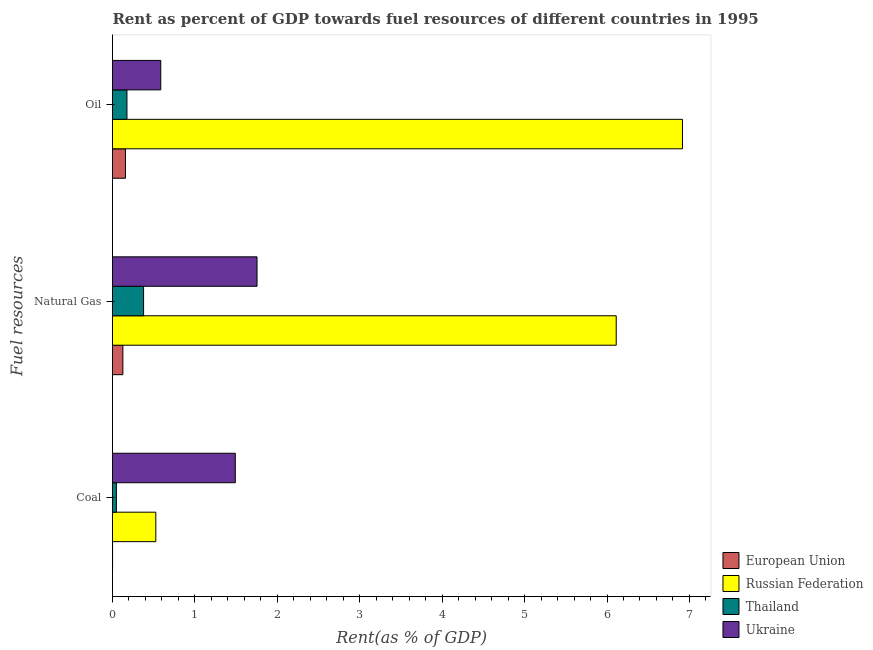How many different coloured bars are there?
Provide a succinct answer. 4. Are the number of bars per tick equal to the number of legend labels?
Provide a succinct answer. Yes. Are the number of bars on each tick of the Y-axis equal?
Provide a succinct answer. Yes. How many bars are there on the 1st tick from the top?
Ensure brevity in your answer.  4. How many bars are there on the 2nd tick from the bottom?
Your answer should be compact. 4. What is the label of the 1st group of bars from the top?
Ensure brevity in your answer.  Oil. What is the rent towards natural gas in Thailand?
Your response must be concise. 0.38. Across all countries, what is the maximum rent towards natural gas?
Your response must be concise. 6.11. Across all countries, what is the minimum rent towards natural gas?
Your response must be concise. 0.13. In which country was the rent towards oil maximum?
Your answer should be compact. Russian Federation. In which country was the rent towards oil minimum?
Ensure brevity in your answer.  European Union. What is the total rent towards natural gas in the graph?
Offer a very short reply. 8.37. What is the difference between the rent towards oil in Russian Federation and that in Ukraine?
Ensure brevity in your answer.  6.33. What is the difference between the rent towards coal in Thailand and the rent towards natural gas in Ukraine?
Your answer should be very brief. -1.71. What is the average rent towards coal per country?
Your answer should be very brief. 0.52. What is the difference between the rent towards coal and rent towards oil in Thailand?
Your answer should be compact. -0.13. What is the ratio of the rent towards natural gas in European Union to that in Russian Federation?
Give a very brief answer. 0.02. Is the rent towards oil in Thailand less than that in Russian Federation?
Your response must be concise. Yes. What is the difference between the highest and the second highest rent towards coal?
Ensure brevity in your answer.  0.96. What is the difference between the highest and the lowest rent towards natural gas?
Provide a succinct answer. 5.99. What does the 1st bar from the top in Coal represents?
Keep it short and to the point. Ukraine. What does the 1st bar from the bottom in Coal represents?
Offer a very short reply. European Union. How many countries are there in the graph?
Your answer should be very brief. 4. Are the values on the major ticks of X-axis written in scientific E-notation?
Provide a short and direct response. No. Does the graph contain any zero values?
Give a very brief answer. No. Does the graph contain grids?
Your answer should be very brief. No. How many legend labels are there?
Provide a short and direct response. 4. How are the legend labels stacked?
Offer a very short reply. Vertical. What is the title of the graph?
Offer a terse response. Rent as percent of GDP towards fuel resources of different countries in 1995. Does "Sao Tome and Principe" appear as one of the legend labels in the graph?
Provide a short and direct response. No. What is the label or title of the X-axis?
Keep it short and to the point. Rent(as % of GDP). What is the label or title of the Y-axis?
Make the answer very short. Fuel resources. What is the Rent(as % of GDP) in European Union in Coal?
Your answer should be very brief. 0. What is the Rent(as % of GDP) in Russian Federation in Coal?
Your answer should be very brief. 0.53. What is the Rent(as % of GDP) in Thailand in Coal?
Make the answer very short. 0.05. What is the Rent(as % of GDP) of Ukraine in Coal?
Provide a succinct answer. 1.49. What is the Rent(as % of GDP) in European Union in Natural Gas?
Make the answer very short. 0.13. What is the Rent(as % of GDP) of Russian Federation in Natural Gas?
Offer a very short reply. 6.11. What is the Rent(as % of GDP) of Thailand in Natural Gas?
Your answer should be compact. 0.38. What is the Rent(as % of GDP) in Ukraine in Natural Gas?
Offer a very short reply. 1.75. What is the Rent(as % of GDP) of European Union in Oil?
Your answer should be compact. 0.16. What is the Rent(as % of GDP) of Russian Federation in Oil?
Your response must be concise. 6.92. What is the Rent(as % of GDP) in Thailand in Oil?
Keep it short and to the point. 0.18. What is the Rent(as % of GDP) in Ukraine in Oil?
Offer a very short reply. 0.59. Across all Fuel resources, what is the maximum Rent(as % of GDP) of European Union?
Make the answer very short. 0.16. Across all Fuel resources, what is the maximum Rent(as % of GDP) in Russian Federation?
Your answer should be compact. 6.92. Across all Fuel resources, what is the maximum Rent(as % of GDP) in Thailand?
Offer a very short reply. 0.38. Across all Fuel resources, what is the maximum Rent(as % of GDP) in Ukraine?
Offer a very short reply. 1.75. Across all Fuel resources, what is the minimum Rent(as % of GDP) of European Union?
Your response must be concise. 0. Across all Fuel resources, what is the minimum Rent(as % of GDP) of Russian Federation?
Your answer should be compact. 0.53. Across all Fuel resources, what is the minimum Rent(as % of GDP) in Thailand?
Your response must be concise. 0.05. Across all Fuel resources, what is the minimum Rent(as % of GDP) of Ukraine?
Make the answer very short. 0.59. What is the total Rent(as % of GDP) of European Union in the graph?
Provide a short and direct response. 0.28. What is the total Rent(as % of GDP) of Russian Federation in the graph?
Make the answer very short. 13.55. What is the total Rent(as % of GDP) in Thailand in the graph?
Keep it short and to the point. 0.6. What is the total Rent(as % of GDP) of Ukraine in the graph?
Provide a short and direct response. 3.83. What is the difference between the Rent(as % of GDP) of European Union in Coal and that in Natural Gas?
Offer a terse response. -0.13. What is the difference between the Rent(as % of GDP) of Russian Federation in Coal and that in Natural Gas?
Ensure brevity in your answer.  -5.59. What is the difference between the Rent(as % of GDP) in Thailand in Coal and that in Natural Gas?
Your answer should be compact. -0.33. What is the difference between the Rent(as % of GDP) of Ukraine in Coal and that in Natural Gas?
Your answer should be very brief. -0.26. What is the difference between the Rent(as % of GDP) in European Union in Coal and that in Oil?
Provide a succinct answer. -0.16. What is the difference between the Rent(as % of GDP) in Russian Federation in Coal and that in Oil?
Keep it short and to the point. -6.39. What is the difference between the Rent(as % of GDP) in Thailand in Coal and that in Oil?
Keep it short and to the point. -0.13. What is the difference between the Rent(as % of GDP) in Ukraine in Coal and that in Oil?
Make the answer very short. 0.9. What is the difference between the Rent(as % of GDP) of European Union in Natural Gas and that in Oil?
Your answer should be very brief. -0.03. What is the difference between the Rent(as % of GDP) in Russian Federation in Natural Gas and that in Oil?
Ensure brevity in your answer.  -0.8. What is the difference between the Rent(as % of GDP) in Thailand in Natural Gas and that in Oil?
Keep it short and to the point. 0.2. What is the difference between the Rent(as % of GDP) of Ukraine in Natural Gas and that in Oil?
Your answer should be compact. 1.17. What is the difference between the Rent(as % of GDP) in European Union in Coal and the Rent(as % of GDP) in Russian Federation in Natural Gas?
Offer a terse response. -6.11. What is the difference between the Rent(as % of GDP) in European Union in Coal and the Rent(as % of GDP) in Thailand in Natural Gas?
Provide a succinct answer. -0.38. What is the difference between the Rent(as % of GDP) in European Union in Coal and the Rent(as % of GDP) in Ukraine in Natural Gas?
Keep it short and to the point. -1.75. What is the difference between the Rent(as % of GDP) in Russian Federation in Coal and the Rent(as % of GDP) in Thailand in Natural Gas?
Your response must be concise. 0.15. What is the difference between the Rent(as % of GDP) in Russian Federation in Coal and the Rent(as % of GDP) in Ukraine in Natural Gas?
Keep it short and to the point. -1.23. What is the difference between the Rent(as % of GDP) of Thailand in Coal and the Rent(as % of GDP) of Ukraine in Natural Gas?
Your answer should be compact. -1.71. What is the difference between the Rent(as % of GDP) in European Union in Coal and the Rent(as % of GDP) in Russian Federation in Oil?
Ensure brevity in your answer.  -6.91. What is the difference between the Rent(as % of GDP) in European Union in Coal and the Rent(as % of GDP) in Thailand in Oil?
Your response must be concise. -0.17. What is the difference between the Rent(as % of GDP) in European Union in Coal and the Rent(as % of GDP) in Ukraine in Oil?
Offer a very short reply. -0.58. What is the difference between the Rent(as % of GDP) in Russian Federation in Coal and the Rent(as % of GDP) in Thailand in Oil?
Your answer should be compact. 0.35. What is the difference between the Rent(as % of GDP) of Russian Federation in Coal and the Rent(as % of GDP) of Ukraine in Oil?
Provide a succinct answer. -0.06. What is the difference between the Rent(as % of GDP) of Thailand in Coal and the Rent(as % of GDP) of Ukraine in Oil?
Provide a succinct answer. -0.54. What is the difference between the Rent(as % of GDP) of European Union in Natural Gas and the Rent(as % of GDP) of Russian Federation in Oil?
Your response must be concise. -6.79. What is the difference between the Rent(as % of GDP) in European Union in Natural Gas and the Rent(as % of GDP) in Thailand in Oil?
Keep it short and to the point. -0.05. What is the difference between the Rent(as % of GDP) in European Union in Natural Gas and the Rent(as % of GDP) in Ukraine in Oil?
Offer a terse response. -0.46. What is the difference between the Rent(as % of GDP) in Russian Federation in Natural Gas and the Rent(as % of GDP) in Thailand in Oil?
Offer a terse response. 5.94. What is the difference between the Rent(as % of GDP) of Russian Federation in Natural Gas and the Rent(as % of GDP) of Ukraine in Oil?
Give a very brief answer. 5.53. What is the difference between the Rent(as % of GDP) of Thailand in Natural Gas and the Rent(as % of GDP) of Ukraine in Oil?
Your answer should be very brief. -0.21. What is the average Rent(as % of GDP) in European Union per Fuel resources?
Your answer should be compact. 0.09. What is the average Rent(as % of GDP) in Russian Federation per Fuel resources?
Make the answer very short. 4.52. What is the average Rent(as % of GDP) in Thailand per Fuel resources?
Keep it short and to the point. 0.2. What is the average Rent(as % of GDP) in Ukraine per Fuel resources?
Ensure brevity in your answer.  1.28. What is the difference between the Rent(as % of GDP) in European Union and Rent(as % of GDP) in Russian Federation in Coal?
Provide a succinct answer. -0.52. What is the difference between the Rent(as % of GDP) in European Union and Rent(as % of GDP) in Thailand in Coal?
Offer a very short reply. -0.05. What is the difference between the Rent(as % of GDP) in European Union and Rent(as % of GDP) in Ukraine in Coal?
Ensure brevity in your answer.  -1.49. What is the difference between the Rent(as % of GDP) of Russian Federation and Rent(as % of GDP) of Thailand in Coal?
Your answer should be very brief. 0.48. What is the difference between the Rent(as % of GDP) in Russian Federation and Rent(as % of GDP) in Ukraine in Coal?
Provide a short and direct response. -0.96. What is the difference between the Rent(as % of GDP) in Thailand and Rent(as % of GDP) in Ukraine in Coal?
Offer a terse response. -1.44. What is the difference between the Rent(as % of GDP) in European Union and Rent(as % of GDP) in Russian Federation in Natural Gas?
Offer a very short reply. -5.99. What is the difference between the Rent(as % of GDP) of European Union and Rent(as % of GDP) of Thailand in Natural Gas?
Offer a very short reply. -0.25. What is the difference between the Rent(as % of GDP) in European Union and Rent(as % of GDP) in Ukraine in Natural Gas?
Offer a terse response. -1.63. What is the difference between the Rent(as % of GDP) in Russian Federation and Rent(as % of GDP) in Thailand in Natural Gas?
Provide a short and direct response. 5.73. What is the difference between the Rent(as % of GDP) of Russian Federation and Rent(as % of GDP) of Ukraine in Natural Gas?
Offer a very short reply. 4.36. What is the difference between the Rent(as % of GDP) in Thailand and Rent(as % of GDP) in Ukraine in Natural Gas?
Make the answer very short. -1.38. What is the difference between the Rent(as % of GDP) of European Union and Rent(as % of GDP) of Russian Federation in Oil?
Your response must be concise. -6.76. What is the difference between the Rent(as % of GDP) of European Union and Rent(as % of GDP) of Thailand in Oil?
Your answer should be very brief. -0.02. What is the difference between the Rent(as % of GDP) in European Union and Rent(as % of GDP) in Ukraine in Oil?
Provide a succinct answer. -0.43. What is the difference between the Rent(as % of GDP) in Russian Federation and Rent(as % of GDP) in Thailand in Oil?
Make the answer very short. 6.74. What is the difference between the Rent(as % of GDP) of Russian Federation and Rent(as % of GDP) of Ukraine in Oil?
Your answer should be very brief. 6.33. What is the difference between the Rent(as % of GDP) of Thailand and Rent(as % of GDP) of Ukraine in Oil?
Your answer should be compact. -0.41. What is the ratio of the Rent(as % of GDP) of European Union in Coal to that in Natural Gas?
Ensure brevity in your answer.  0. What is the ratio of the Rent(as % of GDP) in Russian Federation in Coal to that in Natural Gas?
Your response must be concise. 0.09. What is the ratio of the Rent(as % of GDP) of Thailand in Coal to that in Natural Gas?
Ensure brevity in your answer.  0.13. What is the ratio of the Rent(as % of GDP) of Ukraine in Coal to that in Natural Gas?
Offer a terse response. 0.85. What is the ratio of the Rent(as % of GDP) of European Union in Coal to that in Oil?
Give a very brief answer. 0. What is the ratio of the Rent(as % of GDP) in Russian Federation in Coal to that in Oil?
Offer a very short reply. 0.08. What is the ratio of the Rent(as % of GDP) in Thailand in Coal to that in Oil?
Your response must be concise. 0.27. What is the ratio of the Rent(as % of GDP) in Ukraine in Coal to that in Oil?
Offer a very short reply. 2.54. What is the ratio of the Rent(as % of GDP) of European Union in Natural Gas to that in Oil?
Your answer should be very brief. 0.8. What is the ratio of the Rent(as % of GDP) of Russian Federation in Natural Gas to that in Oil?
Offer a terse response. 0.88. What is the ratio of the Rent(as % of GDP) in Thailand in Natural Gas to that in Oil?
Provide a short and direct response. 2.15. What is the ratio of the Rent(as % of GDP) in Ukraine in Natural Gas to that in Oil?
Make the answer very short. 3. What is the difference between the highest and the second highest Rent(as % of GDP) in European Union?
Keep it short and to the point. 0.03. What is the difference between the highest and the second highest Rent(as % of GDP) of Russian Federation?
Give a very brief answer. 0.8. What is the difference between the highest and the second highest Rent(as % of GDP) in Thailand?
Keep it short and to the point. 0.2. What is the difference between the highest and the second highest Rent(as % of GDP) in Ukraine?
Your response must be concise. 0.26. What is the difference between the highest and the lowest Rent(as % of GDP) in European Union?
Give a very brief answer. 0.16. What is the difference between the highest and the lowest Rent(as % of GDP) in Russian Federation?
Make the answer very short. 6.39. What is the difference between the highest and the lowest Rent(as % of GDP) of Thailand?
Provide a short and direct response. 0.33. What is the difference between the highest and the lowest Rent(as % of GDP) of Ukraine?
Your answer should be compact. 1.17. 